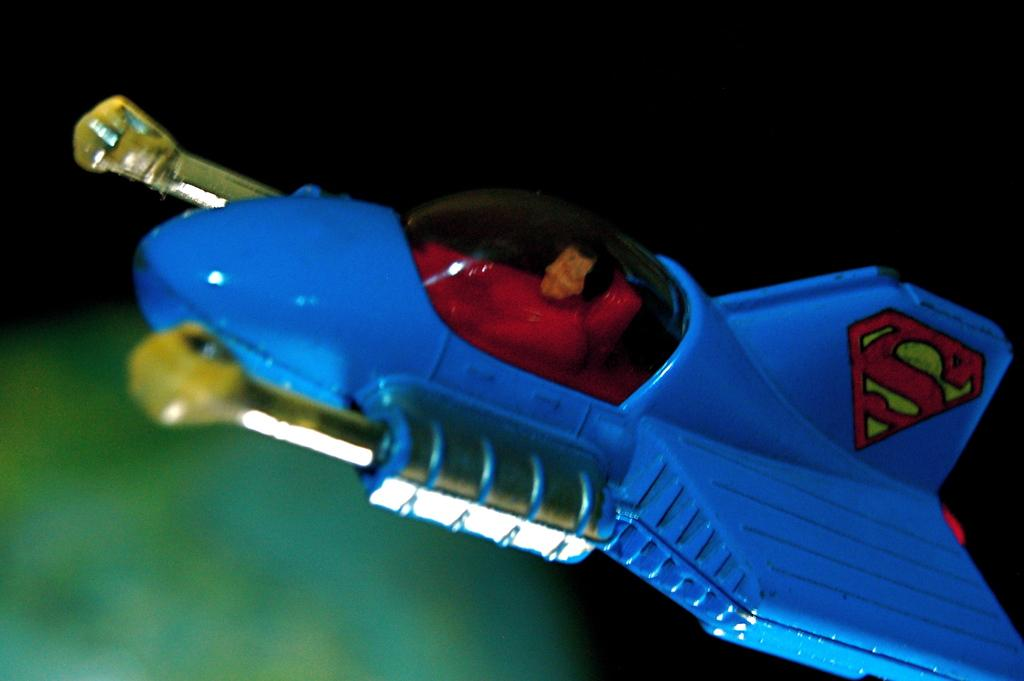<image>
Share a concise interpretation of the image provided. A BLUE TOY ROCKETSHIP WITH THE SUPERMAN LOGO ON THE BACK. 